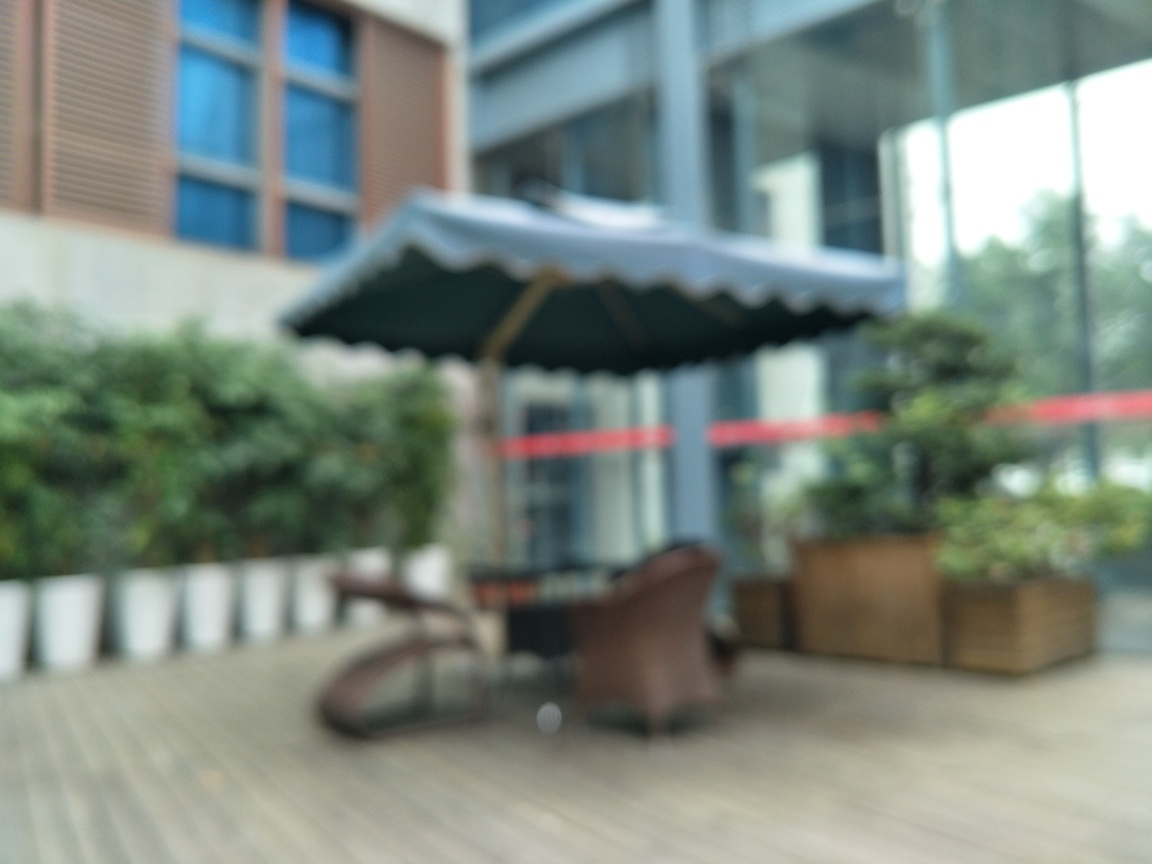Can you describe the mood or atmosphere this blurry image might evoke? The blurred nature of the image gives it a dreamy, mysterious quality. It might evoke a sense of calmness or possibly disorientation, as the lack of detail can lead to an impressionistic interpretation where viewers fill in the gaps with their imagination. 